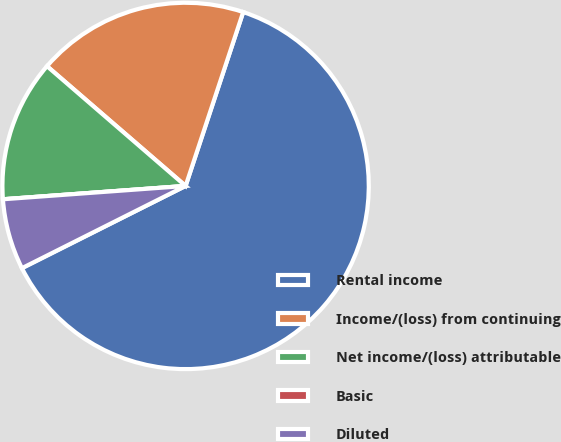<chart> <loc_0><loc_0><loc_500><loc_500><pie_chart><fcel>Rental income<fcel>Income/(loss) from continuing<fcel>Net income/(loss) attributable<fcel>Basic<fcel>Diluted<nl><fcel>62.5%<fcel>18.75%<fcel>12.5%<fcel>0.0%<fcel>6.25%<nl></chart> 